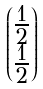Convert formula to latex. <formula><loc_0><loc_0><loc_500><loc_500>\begin{pmatrix} \frac { 1 } { 2 } \\ \frac { 1 } { 2 } \end{pmatrix}</formula> 